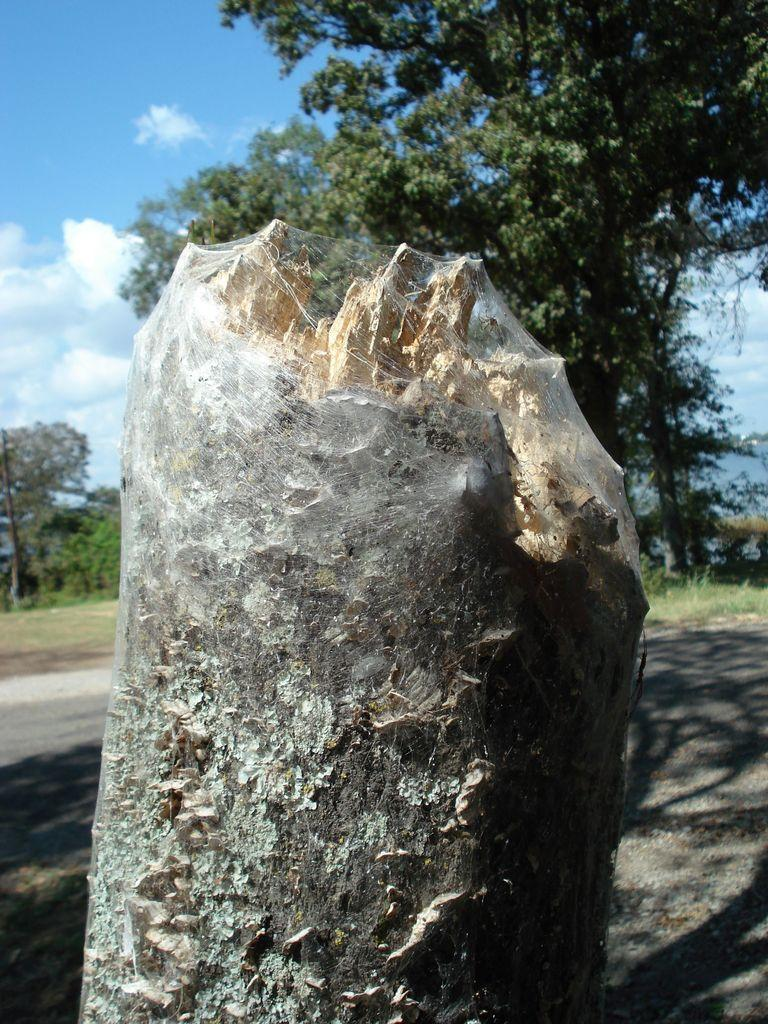What is the main subject of the image? The main subject of the image is a broken leg. Where is the broken leg located in the image? The broken leg is in the center of the image. What can be seen in the background of the image? There are trees in the background of the image. What type of winter sport is being played in the image? There is no winter sport or any indication of winter in the image; it features a broken leg and trees in the background. 